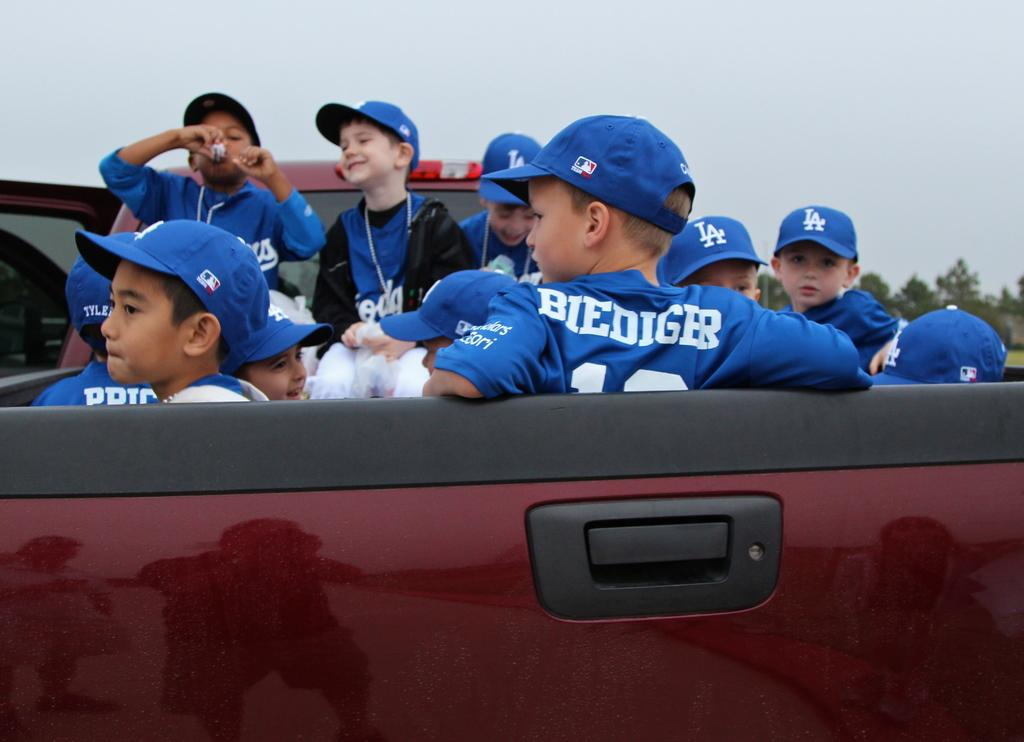<image>
Relay a brief, clear account of the picture shown. Kids sitting in the back of a truck, one of them is named Biediger. 